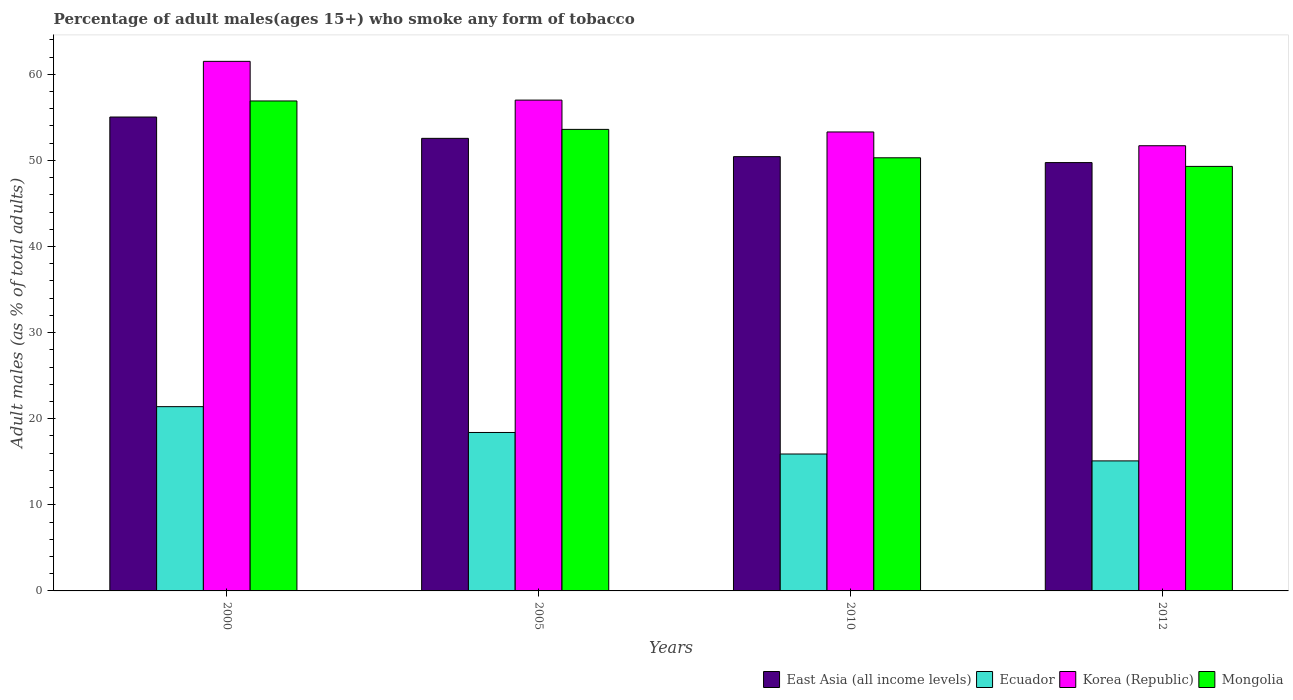How many different coloured bars are there?
Provide a short and direct response. 4. How many groups of bars are there?
Keep it short and to the point. 4. How many bars are there on the 3rd tick from the right?
Your answer should be very brief. 4. What is the label of the 3rd group of bars from the left?
Your response must be concise. 2010. In how many cases, is the number of bars for a given year not equal to the number of legend labels?
Offer a terse response. 0. What is the percentage of adult males who smoke in East Asia (all income levels) in 2000?
Your answer should be very brief. 55.03. Across all years, what is the maximum percentage of adult males who smoke in Ecuador?
Your answer should be very brief. 21.4. Across all years, what is the minimum percentage of adult males who smoke in East Asia (all income levels)?
Your response must be concise. 49.74. In which year was the percentage of adult males who smoke in East Asia (all income levels) minimum?
Your answer should be compact. 2012. What is the total percentage of adult males who smoke in East Asia (all income levels) in the graph?
Offer a very short reply. 207.77. What is the difference between the percentage of adult males who smoke in Ecuador in 2000 and that in 2005?
Your answer should be very brief. 3. What is the difference between the percentage of adult males who smoke in East Asia (all income levels) in 2000 and the percentage of adult males who smoke in Korea (Republic) in 2005?
Your answer should be very brief. -1.97. What is the average percentage of adult males who smoke in Korea (Republic) per year?
Offer a very short reply. 55.88. In the year 2005, what is the difference between the percentage of adult males who smoke in Ecuador and percentage of adult males who smoke in East Asia (all income levels)?
Make the answer very short. -34.16. In how many years, is the percentage of adult males who smoke in East Asia (all income levels) greater than 32 %?
Your response must be concise. 4. What is the ratio of the percentage of adult males who smoke in Korea (Republic) in 2005 to that in 2012?
Your response must be concise. 1.1. Is the percentage of adult males who smoke in Ecuador in 2000 less than that in 2010?
Keep it short and to the point. No. What is the difference between the highest and the second highest percentage of adult males who smoke in Ecuador?
Make the answer very short. 3. What is the difference between the highest and the lowest percentage of adult males who smoke in Mongolia?
Provide a succinct answer. 7.6. Is it the case that in every year, the sum of the percentage of adult males who smoke in Korea (Republic) and percentage of adult males who smoke in Mongolia is greater than the sum of percentage of adult males who smoke in Ecuador and percentage of adult males who smoke in East Asia (all income levels)?
Your answer should be compact. No. What does the 2nd bar from the left in 2005 represents?
Keep it short and to the point. Ecuador. What does the 4th bar from the right in 2010 represents?
Keep it short and to the point. East Asia (all income levels). How many years are there in the graph?
Provide a short and direct response. 4. What is the difference between two consecutive major ticks on the Y-axis?
Provide a short and direct response. 10. Does the graph contain any zero values?
Give a very brief answer. No. Where does the legend appear in the graph?
Your answer should be compact. Bottom right. How many legend labels are there?
Offer a very short reply. 4. How are the legend labels stacked?
Offer a terse response. Horizontal. What is the title of the graph?
Keep it short and to the point. Percentage of adult males(ages 15+) who smoke any form of tobacco. Does "Monaco" appear as one of the legend labels in the graph?
Provide a short and direct response. No. What is the label or title of the Y-axis?
Your response must be concise. Adult males (as % of total adults). What is the Adult males (as % of total adults) of East Asia (all income levels) in 2000?
Give a very brief answer. 55.03. What is the Adult males (as % of total adults) in Ecuador in 2000?
Ensure brevity in your answer.  21.4. What is the Adult males (as % of total adults) of Korea (Republic) in 2000?
Your answer should be very brief. 61.5. What is the Adult males (as % of total adults) in Mongolia in 2000?
Keep it short and to the point. 56.9. What is the Adult males (as % of total adults) of East Asia (all income levels) in 2005?
Keep it short and to the point. 52.56. What is the Adult males (as % of total adults) in Korea (Republic) in 2005?
Provide a short and direct response. 57. What is the Adult males (as % of total adults) of Mongolia in 2005?
Provide a short and direct response. 53.6. What is the Adult males (as % of total adults) in East Asia (all income levels) in 2010?
Your answer should be compact. 50.43. What is the Adult males (as % of total adults) in Ecuador in 2010?
Offer a terse response. 15.9. What is the Adult males (as % of total adults) in Korea (Republic) in 2010?
Make the answer very short. 53.3. What is the Adult males (as % of total adults) of Mongolia in 2010?
Keep it short and to the point. 50.3. What is the Adult males (as % of total adults) in East Asia (all income levels) in 2012?
Give a very brief answer. 49.74. What is the Adult males (as % of total adults) of Ecuador in 2012?
Offer a very short reply. 15.1. What is the Adult males (as % of total adults) in Korea (Republic) in 2012?
Your answer should be very brief. 51.7. What is the Adult males (as % of total adults) of Mongolia in 2012?
Your response must be concise. 49.3. Across all years, what is the maximum Adult males (as % of total adults) in East Asia (all income levels)?
Give a very brief answer. 55.03. Across all years, what is the maximum Adult males (as % of total adults) in Ecuador?
Keep it short and to the point. 21.4. Across all years, what is the maximum Adult males (as % of total adults) of Korea (Republic)?
Make the answer very short. 61.5. Across all years, what is the maximum Adult males (as % of total adults) of Mongolia?
Your answer should be very brief. 56.9. Across all years, what is the minimum Adult males (as % of total adults) of East Asia (all income levels)?
Provide a succinct answer. 49.74. Across all years, what is the minimum Adult males (as % of total adults) in Korea (Republic)?
Provide a succinct answer. 51.7. Across all years, what is the minimum Adult males (as % of total adults) of Mongolia?
Ensure brevity in your answer.  49.3. What is the total Adult males (as % of total adults) in East Asia (all income levels) in the graph?
Offer a very short reply. 207.77. What is the total Adult males (as % of total adults) in Ecuador in the graph?
Your response must be concise. 70.8. What is the total Adult males (as % of total adults) in Korea (Republic) in the graph?
Your answer should be very brief. 223.5. What is the total Adult males (as % of total adults) in Mongolia in the graph?
Keep it short and to the point. 210.1. What is the difference between the Adult males (as % of total adults) in East Asia (all income levels) in 2000 and that in 2005?
Provide a succinct answer. 2.48. What is the difference between the Adult males (as % of total adults) of Ecuador in 2000 and that in 2005?
Keep it short and to the point. 3. What is the difference between the Adult males (as % of total adults) in Mongolia in 2000 and that in 2005?
Provide a succinct answer. 3.3. What is the difference between the Adult males (as % of total adults) in East Asia (all income levels) in 2000 and that in 2010?
Give a very brief answer. 4.6. What is the difference between the Adult males (as % of total adults) in East Asia (all income levels) in 2000 and that in 2012?
Offer a terse response. 5.29. What is the difference between the Adult males (as % of total adults) in Ecuador in 2000 and that in 2012?
Keep it short and to the point. 6.3. What is the difference between the Adult males (as % of total adults) of Mongolia in 2000 and that in 2012?
Offer a terse response. 7.6. What is the difference between the Adult males (as % of total adults) of East Asia (all income levels) in 2005 and that in 2010?
Ensure brevity in your answer.  2.13. What is the difference between the Adult males (as % of total adults) in Korea (Republic) in 2005 and that in 2010?
Your answer should be very brief. 3.7. What is the difference between the Adult males (as % of total adults) in Mongolia in 2005 and that in 2010?
Ensure brevity in your answer.  3.3. What is the difference between the Adult males (as % of total adults) in East Asia (all income levels) in 2005 and that in 2012?
Your answer should be very brief. 2.81. What is the difference between the Adult males (as % of total adults) in Ecuador in 2005 and that in 2012?
Keep it short and to the point. 3.3. What is the difference between the Adult males (as % of total adults) in Korea (Republic) in 2005 and that in 2012?
Keep it short and to the point. 5.3. What is the difference between the Adult males (as % of total adults) of Mongolia in 2005 and that in 2012?
Your answer should be very brief. 4.3. What is the difference between the Adult males (as % of total adults) of East Asia (all income levels) in 2010 and that in 2012?
Ensure brevity in your answer.  0.69. What is the difference between the Adult males (as % of total adults) in Korea (Republic) in 2010 and that in 2012?
Keep it short and to the point. 1.6. What is the difference between the Adult males (as % of total adults) in Mongolia in 2010 and that in 2012?
Keep it short and to the point. 1. What is the difference between the Adult males (as % of total adults) of East Asia (all income levels) in 2000 and the Adult males (as % of total adults) of Ecuador in 2005?
Ensure brevity in your answer.  36.63. What is the difference between the Adult males (as % of total adults) of East Asia (all income levels) in 2000 and the Adult males (as % of total adults) of Korea (Republic) in 2005?
Provide a succinct answer. -1.97. What is the difference between the Adult males (as % of total adults) in East Asia (all income levels) in 2000 and the Adult males (as % of total adults) in Mongolia in 2005?
Ensure brevity in your answer.  1.43. What is the difference between the Adult males (as % of total adults) of Ecuador in 2000 and the Adult males (as % of total adults) of Korea (Republic) in 2005?
Make the answer very short. -35.6. What is the difference between the Adult males (as % of total adults) in Ecuador in 2000 and the Adult males (as % of total adults) in Mongolia in 2005?
Ensure brevity in your answer.  -32.2. What is the difference between the Adult males (as % of total adults) in Korea (Republic) in 2000 and the Adult males (as % of total adults) in Mongolia in 2005?
Your answer should be very brief. 7.9. What is the difference between the Adult males (as % of total adults) in East Asia (all income levels) in 2000 and the Adult males (as % of total adults) in Ecuador in 2010?
Your answer should be compact. 39.13. What is the difference between the Adult males (as % of total adults) in East Asia (all income levels) in 2000 and the Adult males (as % of total adults) in Korea (Republic) in 2010?
Offer a terse response. 1.73. What is the difference between the Adult males (as % of total adults) in East Asia (all income levels) in 2000 and the Adult males (as % of total adults) in Mongolia in 2010?
Give a very brief answer. 4.73. What is the difference between the Adult males (as % of total adults) in Ecuador in 2000 and the Adult males (as % of total adults) in Korea (Republic) in 2010?
Ensure brevity in your answer.  -31.9. What is the difference between the Adult males (as % of total adults) in Ecuador in 2000 and the Adult males (as % of total adults) in Mongolia in 2010?
Provide a short and direct response. -28.9. What is the difference between the Adult males (as % of total adults) in Korea (Republic) in 2000 and the Adult males (as % of total adults) in Mongolia in 2010?
Your answer should be compact. 11.2. What is the difference between the Adult males (as % of total adults) in East Asia (all income levels) in 2000 and the Adult males (as % of total adults) in Ecuador in 2012?
Provide a short and direct response. 39.93. What is the difference between the Adult males (as % of total adults) in East Asia (all income levels) in 2000 and the Adult males (as % of total adults) in Korea (Republic) in 2012?
Make the answer very short. 3.33. What is the difference between the Adult males (as % of total adults) in East Asia (all income levels) in 2000 and the Adult males (as % of total adults) in Mongolia in 2012?
Provide a succinct answer. 5.73. What is the difference between the Adult males (as % of total adults) of Ecuador in 2000 and the Adult males (as % of total adults) of Korea (Republic) in 2012?
Make the answer very short. -30.3. What is the difference between the Adult males (as % of total adults) in Ecuador in 2000 and the Adult males (as % of total adults) in Mongolia in 2012?
Your answer should be compact. -27.9. What is the difference between the Adult males (as % of total adults) of Korea (Republic) in 2000 and the Adult males (as % of total adults) of Mongolia in 2012?
Provide a short and direct response. 12.2. What is the difference between the Adult males (as % of total adults) of East Asia (all income levels) in 2005 and the Adult males (as % of total adults) of Ecuador in 2010?
Provide a succinct answer. 36.66. What is the difference between the Adult males (as % of total adults) in East Asia (all income levels) in 2005 and the Adult males (as % of total adults) in Korea (Republic) in 2010?
Give a very brief answer. -0.74. What is the difference between the Adult males (as % of total adults) in East Asia (all income levels) in 2005 and the Adult males (as % of total adults) in Mongolia in 2010?
Your answer should be compact. 2.26. What is the difference between the Adult males (as % of total adults) of Ecuador in 2005 and the Adult males (as % of total adults) of Korea (Republic) in 2010?
Your answer should be very brief. -34.9. What is the difference between the Adult males (as % of total adults) of Ecuador in 2005 and the Adult males (as % of total adults) of Mongolia in 2010?
Your answer should be very brief. -31.9. What is the difference between the Adult males (as % of total adults) in Korea (Republic) in 2005 and the Adult males (as % of total adults) in Mongolia in 2010?
Offer a terse response. 6.7. What is the difference between the Adult males (as % of total adults) in East Asia (all income levels) in 2005 and the Adult males (as % of total adults) in Ecuador in 2012?
Make the answer very short. 37.46. What is the difference between the Adult males (as % of total adults) of East Asia (all income levels) in 2005 and the Adult males (as % of total adults) of Korea (Republic) in 2012?
Provide a short and direct response. 0.86. What is the difference between the Adult males (as % of total adults) of East Asia (all income levels) in 2005 and the Adult males (as % of total adults) of Mongolia in 2012?
Provide a succinct answer. 3.26. What is the difference between the Adult males (as % of total adults) of Ecuador in 2005 and the Adult males (as % of total adults) of Korea (Republic) in 2012?
Ensure brevity in your answer.  -33.3. What is the difference between the Adult males (as % of total adults) in Ecuador in 2005 and the Adult males (as % of total adults) in Mongolia in 2012?
Offer a very short reply. -30.9. What is the difference between the Adult males (as % of total adults) of East Asia (all income levels) in 2010 and the Adult males (as % of total adults) of Ecuador in 2012?
Your answer should be very brief. 35.33. What is the difference between the Adult males (as % of total adults) in East Asia (all income levels) in 2010 and the Adult males (as % of total adults) in Korea (Republic) in 2012?
Ensure brevity in your answer.  -1.27. What is the difference between the Adult males (as % of total adults) of East Asia (all income levels) in 2010 and the Adult males (as % of total adults) of Mongolia in 2012?
Your answer should be compact. 1.13. What is the difference between the Adult males (as % of total adults) in Ecuador in 2010 and the Adult males (as % of total adults) in Korea (Republic) in 2012?
Keep it short and to the point. -35.8. What is the difference between the Adult males (as % of total adults) of Ecuador in 2010 and the Adult males (as % of total adults) of Mongolia in 2012?
Provide a short and direct response. -33.4. What is the average Adult males (as % of total adults) in East Asia (all income levels) per year?
Make the answer very short. 51.94. What is the average Adult males (as % of total adults) in Ecuador per year?
Provide a succinct answer. 17.7. What is the average Adult males (as % of total adults) in Korea (Republic) per year?
Make the answer very short. 55.88. What is the average Adult males (as % of total adults) of Mongolia per year?
Provide a succinct answer. 52.52. In the year 2000, what is the difference between the Adult males (as % of total adults) of East Asia (all income levels) and Adult males (as % of total adults) of Ecuador?
Make the answer very short. 33.63. In the year 2000, what is the difference between the Adult males (as % of total adults) of East Asia (all income levels) and Adult males (as % of total adults) of Korea (Republic)?
Your answer should be compact. -6.47. In the year 2000, what is the difference between the Adult males (as % of total adults) in East Asia (all income levels) and Adult males (as % of total adults) in Mongolia?
Ensure brevity in your answer.  -1.87. In the year 2000, what is the difference between the Adult males (as % of total adults) of Ecuador and Adult males (as % of total adults) of Korea (Republic)?
Give a very brief answer. -40.1. In the year 2000, what is the difference between the Adult males (as % of total adults) of Ecuador and Adult males (as % of total adults) of Mongolia?
Offer a terse response. -35.5. In the year 2000, what is the difference between the Adult males (as % of total adults) in Korea (Republic) and Adult males (as % of total adults) in Mongolia?
Ensure brevity in your answer.  4.6. In the year 2005, what is the difference between the Adult males (as % of total adults) of East Asia (all income levels) and Adult males (as % of total adults) of Ecuador?
Keep it short and to the point. 34.16. In the year 2005, what is the difference between the Adult males (as % of total adults) of East Asia (all income levels) and Adult males (as % of total adults) of Korea (Republic)?
Your response must be concise. -4.44. In the year 2005, what is the difference between the Adult males (as % of total adults) in East Asia (all income levels) and Adult males (as % of total adults) in Mongolia?
Provide a short and direct response. -1.04. In the year 2005, what is the difference between the Adult males (as % of total adults) of Ecuador and Adult males (as % of total adults) of Korea (Republic)?
Offer a very short reply. -38.6. In the year 2005, what is the difference between the Adult males (as % of total adults) in Ecuador and Adult males (as % of total adults) in Mongolia?
Your answer should be compact. -35.2. In the year 2005, what is the difference between the Adult males (as % of total adults) of Korea (Republic) and Adult males (as % of total adults) of Mongolia?
Ensure brevity in your answer.  3.4. In the year 2010, what is the difference between the Adult males (as % of total adults) in East Asia (all income levels) and Adult males (as % of total adults) in Ecuador?
Provide a succinct answer. 34.53. In the year 2010, what is the difference between the Adult males (as % of total adults) in East Asia (all income levels) and Adult males (as % of total adults) in Korea (Republic)?
Your answer should be very brief. -2.87. In the year 2010, what is the difference between the Adult males (as % of total adults) in East Asia (all income levels) and Adult males (as % of total adults) in Mongolia?
Your response must be concise. 0.13. In the year 2010, what is the difference between the Adult males (as % of total adults) of Ecuador and Adult males (as % of total adults) of Korea (Republic)?
Your response must be concise. -37.4. In the year 2010, what is the difference between the Adult males (as % of total adults) in Ecuador and Adult males (as % of total adults) in Mongolia?
Your response must be concise. -34.4. In the year 2010, what is the difference between the Adult males (as % of total adults) in Korea (Republic) and Adult males (as % of total adults) in Mongolia?
Provide a succinct answer. 3. In the year 2012, what is the difference between the Adult males (as % of total adults) in East Asia (all income levels) and Adult males (as % of total adults) in Ecuador?
Provide a short and direct response. 34.64. In the year 2012, what is the difference between the Adult males (as % of total adults) in East Asia (all income levels) and Adult males (as % of total adults) in Korea (Republic)?
Provide a short and direct response. -1.96. In the year 2012, what is the difference between the Adult males (as % of total adults) of East Asia (all income levels) and Adult males (as % of total adults) of Mongolia?
Make the answer very short. 0.44. In the year 2012, what is the difference between the Adult males (as % of total adults) in Ecuador and Adult males (as % of total adults) in Korea (Republic)?
Offer a terse response. -36.6. In the year 2012, what is the difference between the Adult males (as % of total adults) of Ecuador and Adult males (as % of total adults) of Mongolia?
Give a very brief answer. -34.2. What is the ratio of the Adult males (as % of total adults) in East Asia (all income levels) in 2000 to that in 2005?
Keep it short and to the point. 1.05. What is the ratio of the Adult males (as % of total adults) of Ecuador in 2000 to that in 2005?
Keep it short and to the point. 1.16. What is the ratio of the Adult males (as % of total adults) of Korea (Republic) in 2000 to that in 2005?
Your answer should be very brief. 1.08. What is the ratio of the Adult males (as % of total adults) in Mongolia in 2000 to that in 2005?
Keep it short and to the point. 1.06. What is the ratio of the Adult males (as % of total adults) in East Asia (all income levels) in 2000 to that in 2010?
Make the answer very short. 1.09. What is the ratio of the Adult males (as % of total adults) of Ecuador in 2000 to that in 2010?
Provide a short and direct response. 1.35. What is the ratio of the Adult males (as % of total adults) in Korea (Republic) in 2000 to that in 2010?
Your response must be concise. 1.15. What is the ratio of the Adult males (as % of total adults) in Mongolia in 2000 to that in 2010?
Ensure brevity in your answer.  1.13. What is the ratio of the Adult males (as % of total adults) in East Asia (all income levels) in 2000 to that in 2012?
Your response must be concise. 1.11. What is the ratio of the Adult males (as % of total adults) in Ecuador in 2000 to that in 2012?
Provide a succinct answer. 1.42. What is the ratio of the Adult males (as % of total adults) in Korea (Republic) in 2000 to that in 2012?
Your response must be concise. 1.19. What is the ratio of the Adult males (as % of total adults) of Mongolia in 2000 to that in 2012?
Give a very brief answer. 1.15. What is the ratio of the Adult males (as % of total adults) in East Asia (all income levels) in 2005 to that in 2010?
Your response must be concise. 1.04. What is the ratio of the Adult males (as % of total adults) in Ecuador in 2005 to that in 2010?
Ensure brevity in your answer.  1.16. What is the ratio of the Adult males (as % of total adults) of Korea (Republic) in 2005 to that in 2010?
Offer a terse response. 1.07. What is the ratio of the Adult males (as % of total adults) of Mongolia in 2005 to that in 2010?
Keep it short and to the point. 1.07. What is the ratio of the Adult males (as % of total adults) of East Asia (all income levels) in 2005 to that in 2012?
Ensure brevity in your answer.  1.06. What is the ratio of the Adult males (as % of total adults) of Ecuador in 2005 to that in 2012?
Your answer should be very brief. 1.22. What is the ratio of the Adult males (as % of total adults) of Korea (Republic) in 2005 to that in 2012?
Ensure brevity in your answer.  1.1. What is the ratio of the Adult males (as % of total adults) of Mongolia in 2005 to that in 2012?
Give a very brief answer. 1.09. What is the ratio of the Adult males (as % of total adults) in East Asia (all income levels) in 2010 to that in 2012?
Your response must be concise. 1.01. What is the ratio of the Adult males (as % of total adults) in Ecuador in 2010 to that in 2012?
Ensure brevity in your answer.  1.05. What is the ratio of the Adult males (as % of total adults) of Korea (Republic) in 2010 to that in 2012?
Your answer should be compact. 1.03. What is the ratio of the Adult males (as % of total adults) of Mongolia in 2010 to that in 2012?
Provide a short and direct response. 1.02. What is the difference between the highest and the second highest Adult males (as % of total adults) of East Asia (all income levels)?
Provide a succinct answer. 2.48. What is the difference between the highest and the second highest Adult males (as % of total adults) of Mongolia?
Offer a terse response. 3.3. What is the difference between the highest and the lowest Adult males (as % of total adults) in East Asia (all income levels)?
Offer a very short reply. 5.29. What is the difference between the highest and the lowest Adult males (as % of total adults) in Mongolia?
Make the answer very short. 7.6. 